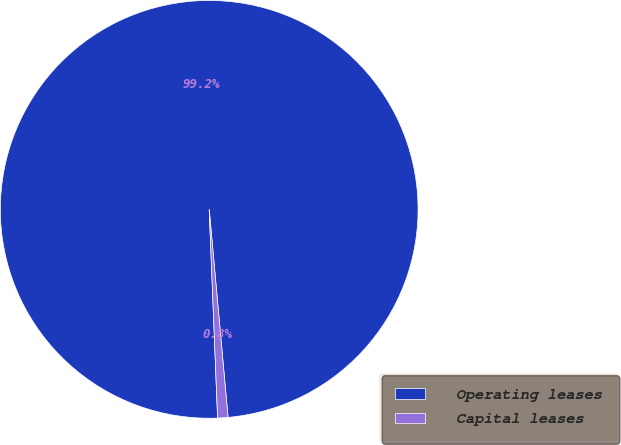Convert chart. <chart><loc_0><loc_0><loc_500><loc_500><pie_chart><fcel>Operating leases<fcel>Capital leases<nl><fcel>99.2%<fcel>0.8%<nl></chart> 